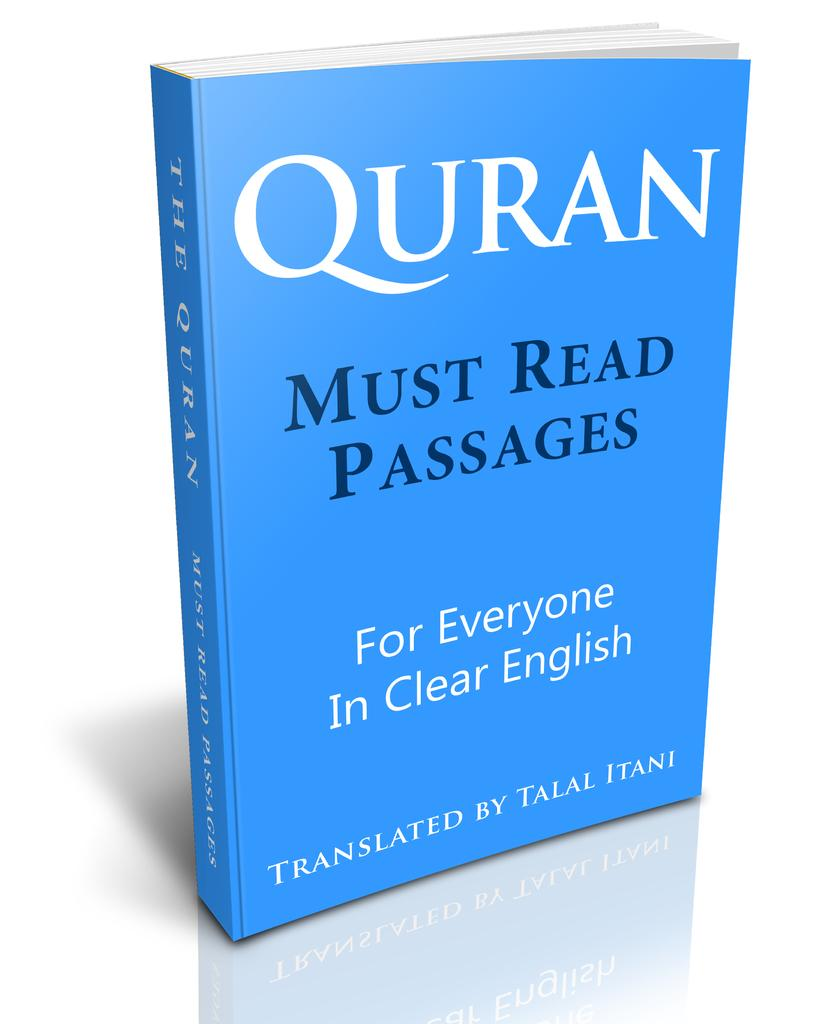<image>
Summarize the visual content of the image. blue paperback copy of quran must read passages for everyone in clear english 